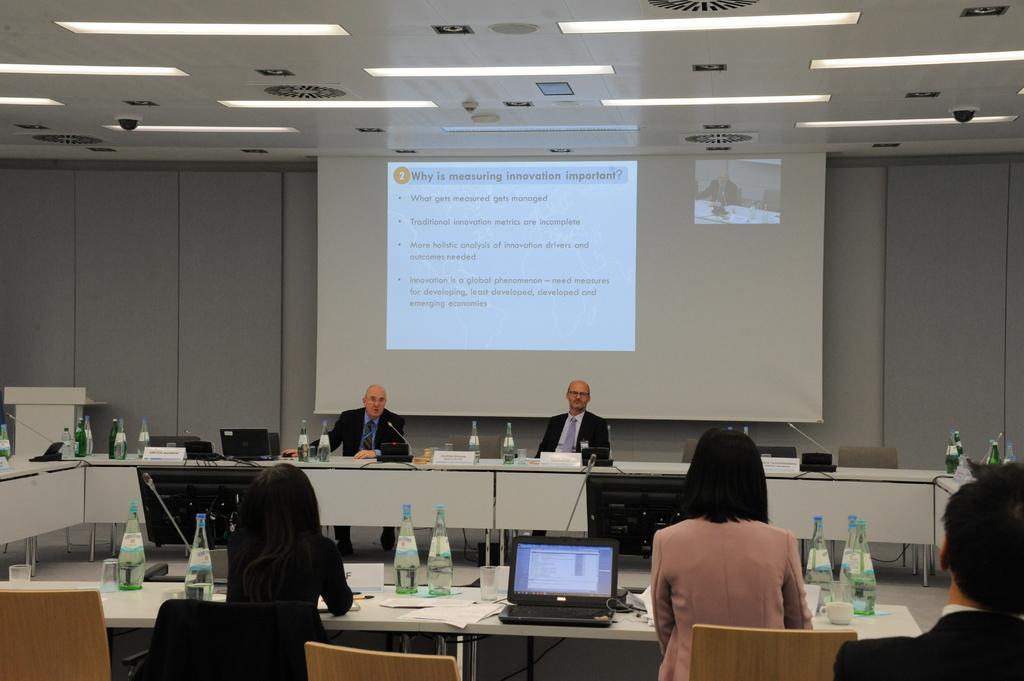How would you summarize this image in a sentence or two? In this image, there are four people sitting on the chairs. I can see the tables with the bottles, papers, laptops, monitors, a cup, mikes and few other objects. At the top of the image, there are ceiling lights, there are ceiling lights and CCTV cameras attached to the ceiling. In the background, I can see a projector screen hanging. At the bottom right corner of the image, I can see another person. 